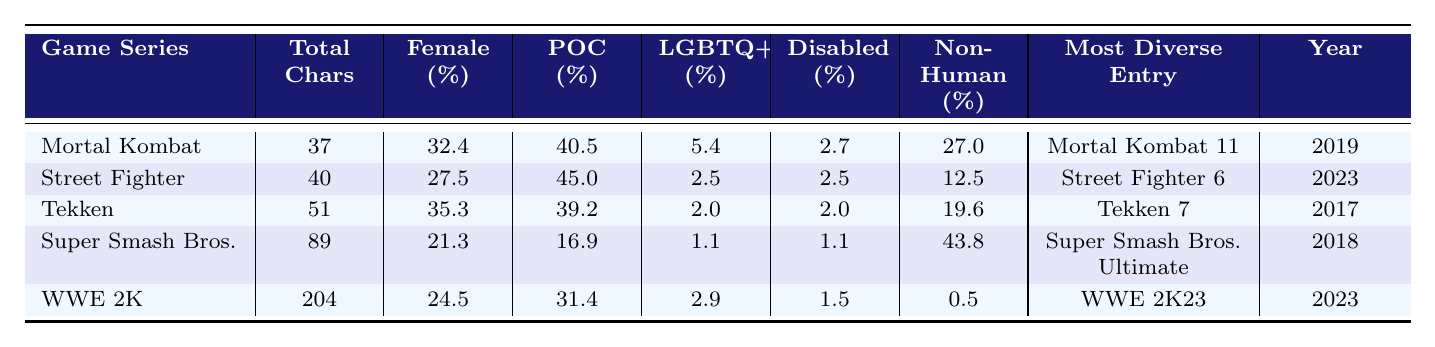What is the total number of characters in the WWE 2K series? According to the table, the total number of characters for the WWE 2K series is listed as 204.
Answer: 204 Which game series has the highest percentage of POC characters? The table shows that Street Fighter has the highest percentage of POC characters at 45.0%.
Answer: Street Fighter What is the percentage of female characters in Mortal Kombat? The table indicates that the percentage of female characters in Mortal Kombat is 32.4%.
Answer: 32.4% What is the average percentage of LGBTQ+ characters across all game series listed? To calculate the average, sum the percentages of LGBTQ+ characters (5.4 + 2.5 + 2.0 + 1.1 + 2.9 = 14.9) and divide by the number of series (5): 14.9/5 = 2.98%.
Answer: 2.98% Which game series has the lowest percentage of non-human characters? The table lists WWE 2K with the lowest percentage of non-human characters at 0.5%.
Answer: WWE 2K Is the percentage of disabled characters higher in the Tekken series or the WWE 2K series? Tekken has a disabled characters percentage of 2.0%, while WWE 2K has 1.5%. Since 2.0% is greater than 1.5%, Tekken has a higher percentage.
Answer: Tekken What year was the most diverse entry for the Super Smash Bros. series? The table states that the most diverse entry for Super Smash Bros. was in the year 2018.
Answer: 2018 How many total characters are there in the series with the highest percentage of female characters? The series with the highest percentage of female characters is Tekken with 35.3%. The total characters in Tekken are 51.
Answer: 51 What is the difference in the percentage of female characters between Mortal Kombat and Super Smash Bros.? The percentage of female characters in Mortal Kombat is 32.4% and in Super Smash Bros. is 21.3%. The difference is 32.4% - 21.3% = 11.1%.
Answer: 11.1% Which game series has the most diverse entry in 2023? The table highlights that both Street Fighter and WWE 2K had their most diverse entries released in 2023.
Answer: Street Fighter and WWE 2K 